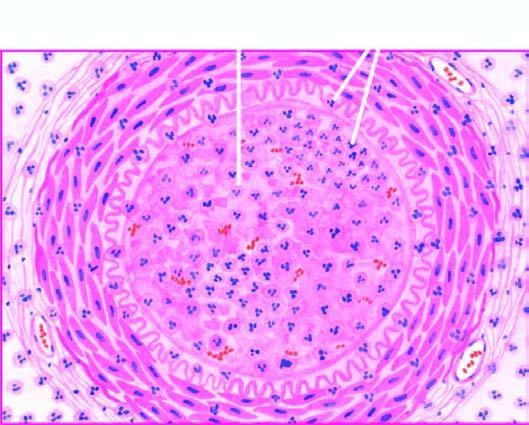s each fibril acute panarteritis?
Answer the question using a single word or phrase. No 